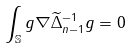Convert formula to latex. <formula><loc_0><loc_0><loc_500><loc_500>\int _ { \mathbb { S } } g \nabla \widetilde { \Delta } _ { n - 1 } ^ { - 1 } g = 0</formula> 